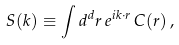Convert formula to latex. <formula><loc_0><loc_0><loc_500><loc_500>S ( { k } ) \equiv \int d ^ { d } r \, e ^ { i { k } \cdot { r } } \, C ( { r } ) \, ,</formula> 